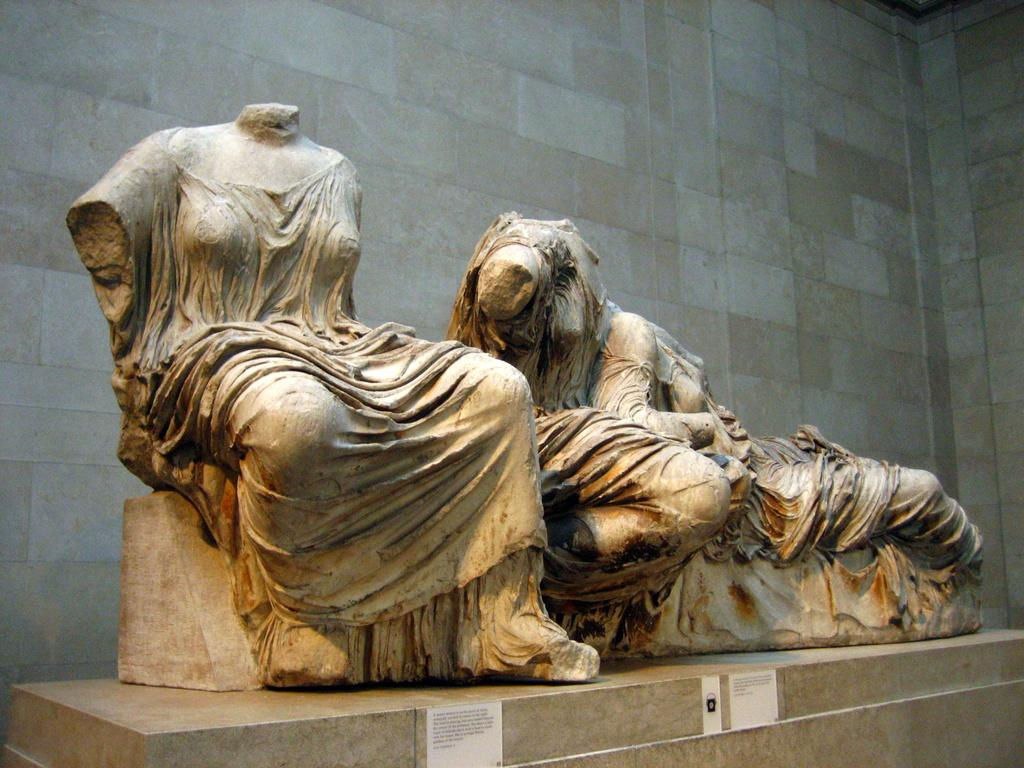What type of art is present in the image? There are sculptures in the image. What type of architectural feature can be seen in the image? There are walls in the image. How many snakes are crawling on the sculptures in the image? There are no snakes present in the image; it only features sculptures and walls. What type of clothing is draped over the sculptures in the image? There is no clothing draped over the sculptures in the image. 